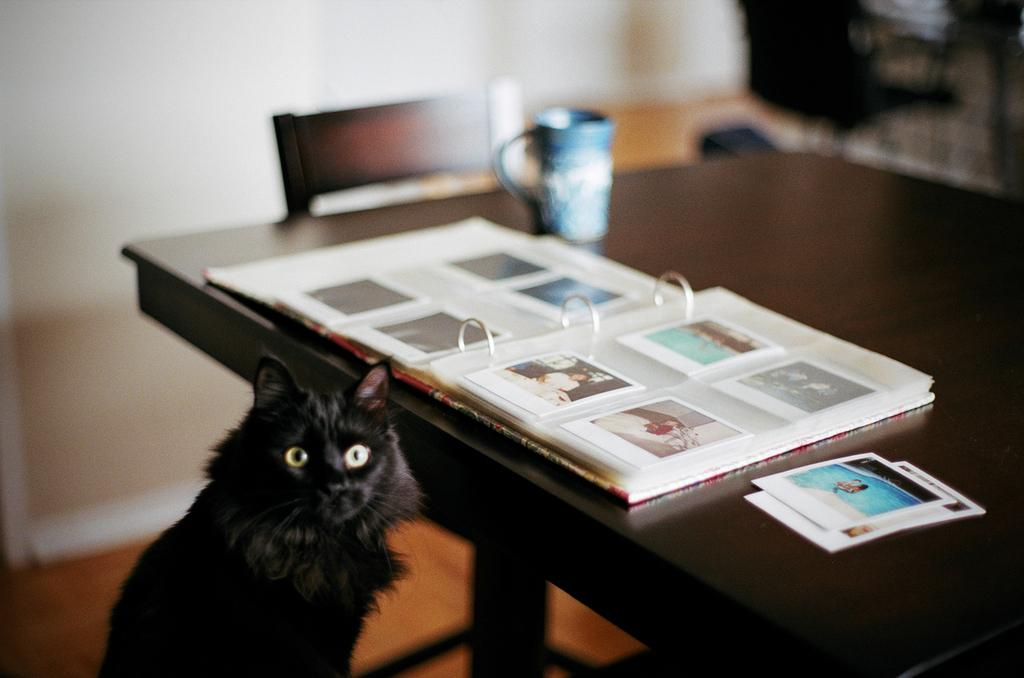What is the main object in the image? There is an album in the image. What else can be seen on the table? There are photos on the table. What type of container is visible in the image? There is a cup in the image. What piece of furniture is present in the image? There is a chair in the image. What type of animal can be seen in the image? There is a black cat in the image. How many houses are visible in the image? There are no houses visible in the image. What part of the cat's body is missing in the image? The image does not show any missing body parts of the cat; the black cat is complete. 